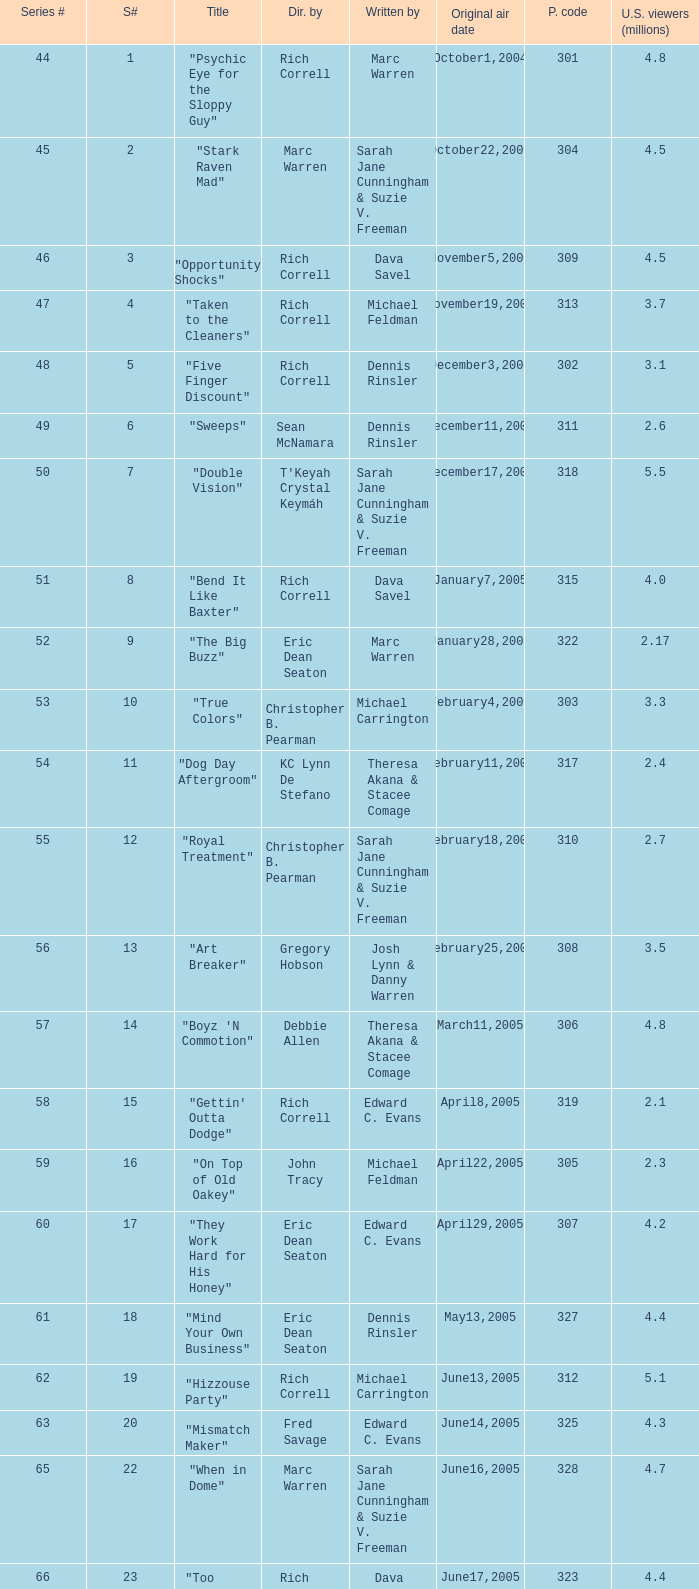What is the title of the episode directed by Rich Correll and written by Dennis Rinsler? "Five Finger Discount". 